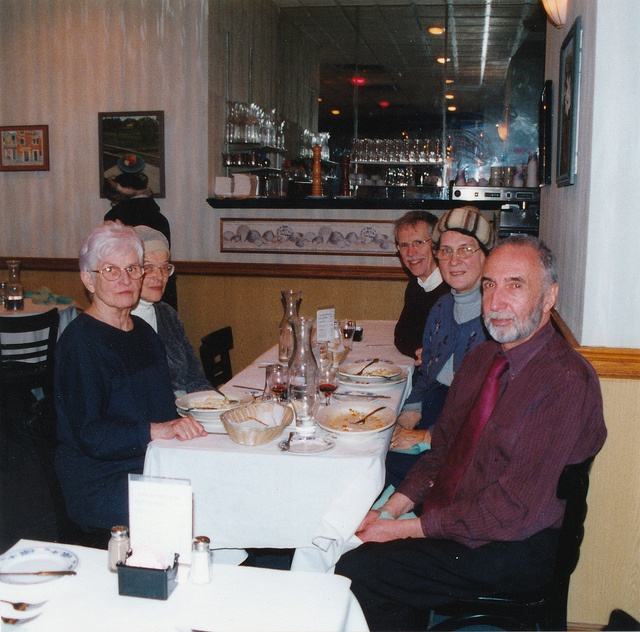Describe the objects in this image and their specific colors. I can see people in gray, black, maroon, purple, and brown tones, dining table in gray, white, blue, and darkgray tones, people in gray, black, brown, darkgray, and navy tones, people in gray, black, brown, and navy tones, and chair in gray, black, and purple tones in this image. 